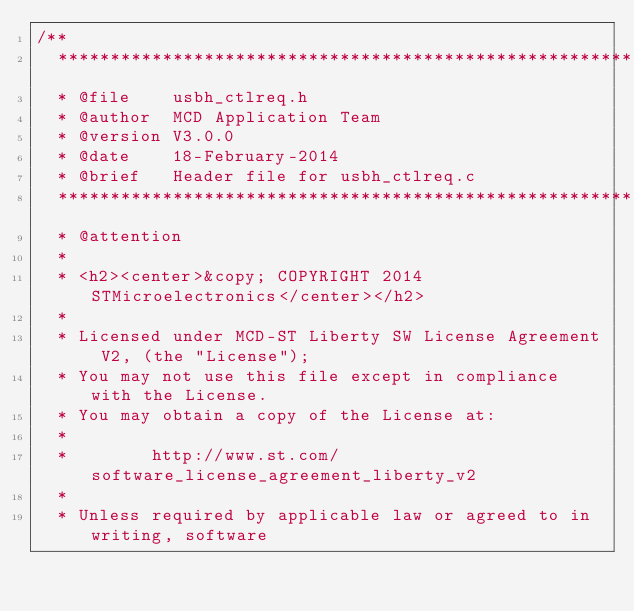<code> <loc_0><loc_0><loc_500><loc_500><_C_>/**
  ******************************************************************************
  * @file    usbh_ctlreq.h
  * @author  MCD Application Team
  * @version V3.0.0
  * @date    18-February-2014
  * @brief   Header file for usbh_ctlreq.c
  ******************************************************************************
  * @attention
  *
  * <h2><center>&copy; COPYRIGHT 2014 STMicroelectronics</center></h2>
  *
  * Licensed under MCD-ST Liberty SW License Agreement V2, (the "License");
  * You may not use this file except in compliance with the License.
  * You may obtain a copy of the License at:
  *
  *        http://www.st.com/software_license_agreement_liberty_v2
  *
  * Unless required by applicable law or agreed to in writing, software</code> 